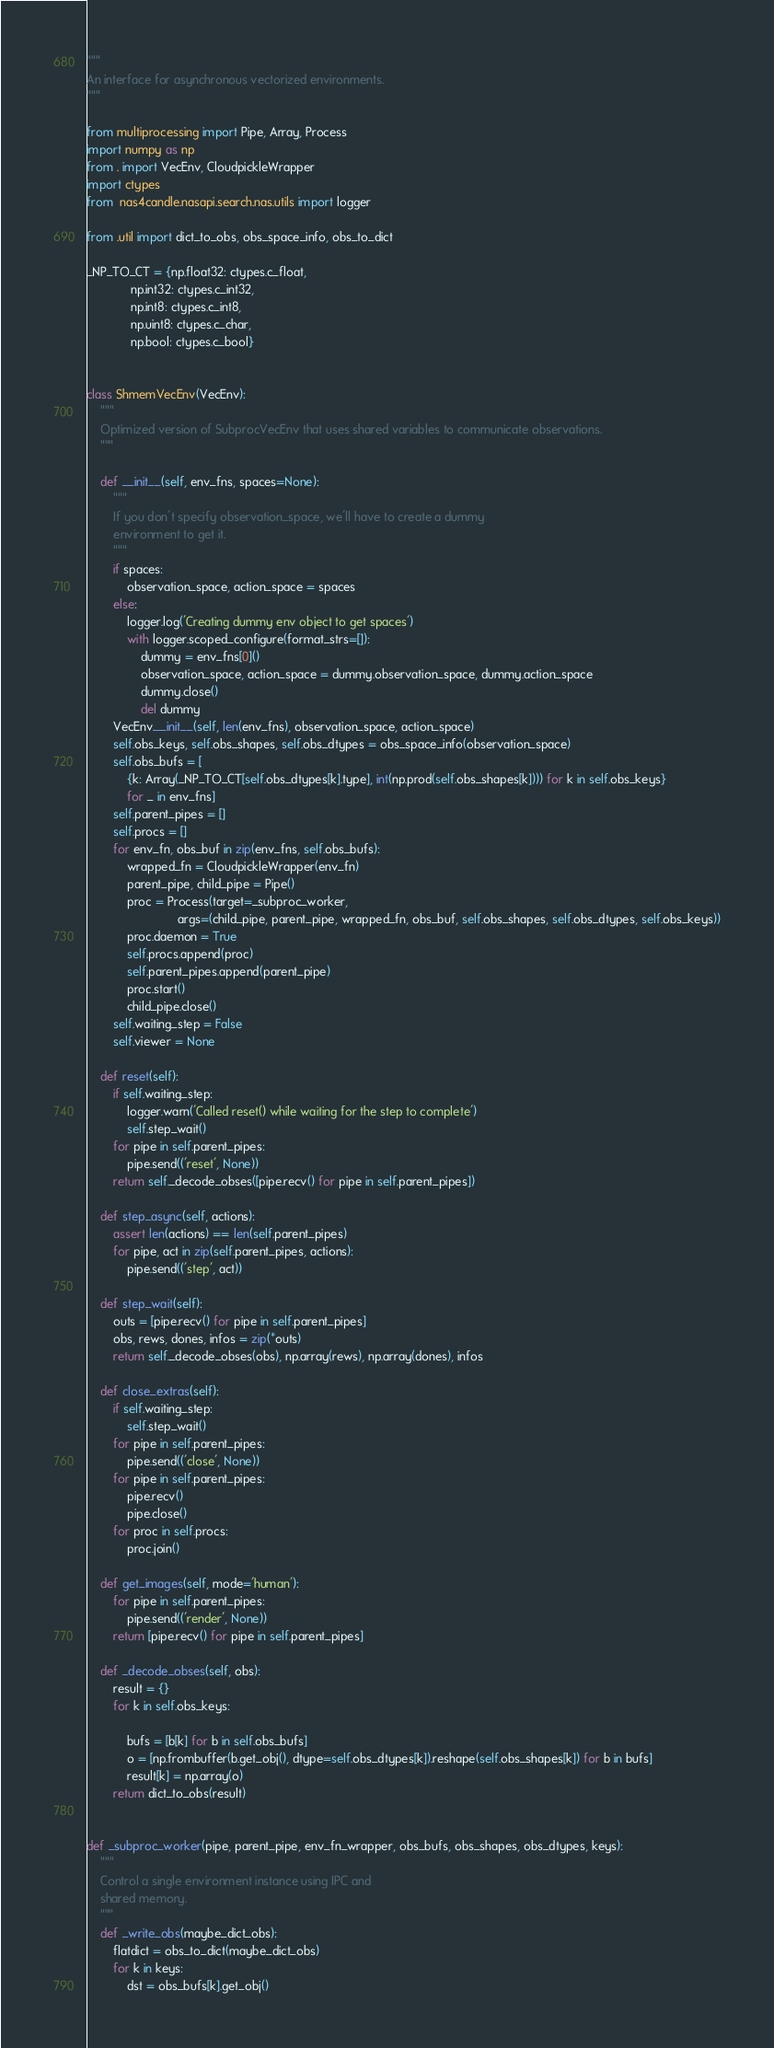<code> <loc_0><loc_0><loc_500><loc_500><_Python_>"""
An interface for asynchronous vectorized environments.
"""

from multiprocessing import Pipe, Array, Process
import numpy as np
from . import VecEnv, CloudpickleWrapper
import ctypes
from  nas4candle.nasapi.search.nas.utils import logger

from .util import dict_to_obs, obs_space_info, obs_to_dict

_NP_TO_CT = {np.float32: ctypes.c_float,
             np.int32: ctypes.c_int32,
             np.int8: ctypes.c_int8,
             np.uint8: ctypes.c_char,
             np.bool: ctypes.c_bool}


class ShmemVecEnv(VecEnv):
    """
    Optimized version of SubprocVecEnv that uses shared variables to communicate observations.
    """

    def __init__(self, env_fns, spaces=None):
        """
        If you don't specify observation_space, we'll have to create a dummy
        environment to get it.
        """
        if spaces:
            observation_space, action_space = spaces
        else:
            logger.log('Creating dummy env object to get spaces')
            with logger.scoped_configure(format_strs=[]):
                dummy = env_fns[0]()
                observation_space, action_space = dummy.observation_space, dummy.action_space
                dummy.close()
                del dummy
        VecEnv.__init__(self, len(env_fns), observation_space, action_space)
        self.obs_keys, self.obs_shapes, self.obs_dtypes = obs_space_info(observation_space)
        self.obs_bufs = [
            {k: Array(_NP_TO_CT[self.obs_dtypes[k].type], int(np.prod(self.obs_shapes[k]))) for k in self.obs_keys}
            for _ in env_fns]
        self.parent_pipes = []
        self.procs = []
        for env_fn, obs_buf in zip(env_fns, self.obs_bufs):
            wrapped_fn = CloudpickleWrapper(env_fn)
            parent_pipe, child_pipe = Pipe()
            proc = Process(target=_subproc_worker,
                           args=(child_pipe, parent_pipe, wrapped_fn, obs_buf, self.obs_shapes, self.obs_dtypes, self.obs_keys))
            proc.daemon = True
            self.procs.append(proc)
            self.parent_pipes.append(parent_pipe)
            proc.start()
            child_pipe.close()
        self.waiting_step = False
        self.viewer = None

    def reset(self):
        if self.waiting_step:
            logger.warn('Called reset() while waiting for the step to complete')
            self.step_wait()
        for pipe in self.parent_pipes:
            pipe.send(('reset', None))
        return self._decode_obses([pipe.recv() for pipe in self.parent_pipes])

    def step_async(self, actions):
        assert len(actions) == len(self.parent_pipes)
        for pipe, act in zip(self.parent_pipes, actions):
            pipe.send(('step', act))

    def step_wait(self):
        outs = [pipe.recv() for pipe in self.parent_pipes]
        obs, rews, dones, infos = zip(*outs)
        return self._decode_obses(obs), np.array(rews), np.array(dones), infos

    def close_extras(self):
        if self.waiting_step:
            self.step_wait()
        for pipe in self.parent_pipes:
            pipe.send(('close', None))
        for pipe in self.parent_pipes:
            pipe.recv()
            pipe.close()
        for proc in self.procs:
            proc.join()

    def get_images(self, mode='human'):
        for pipe in self.parent_pipes:
            pipe.send(('render', None))
        return [pipe.recv() for pipe in self.parent_pipes]

    def _decode_obses(self, obs):
        result = {}
        for k in self.obs_keys:

            bufs = [b[k] for b in self.obs_bufs]
            o = [np.frombuffer(b.get_obj(), dtype=self.obs_dtypes[k]).reshape(self.obs_shapes[k]) for b in bufs]
            result[k] = np.array(o)
        return dict_to_obs(result)


def _subproc_worker(pipe, parent_pipe, env_fn_wrapper, obs_bufs, obs_shapes, obs_dtypes, keys):
    """
    Control a single environment instance using IPC and
    shared memory.
    """
    def _write_obs(maybe_dict_obs):
        flatdict = obs_to_dict(maybe_dict_obs)
        for k in keys:
            dst = obs_bufs[k].get_obj()</code> 